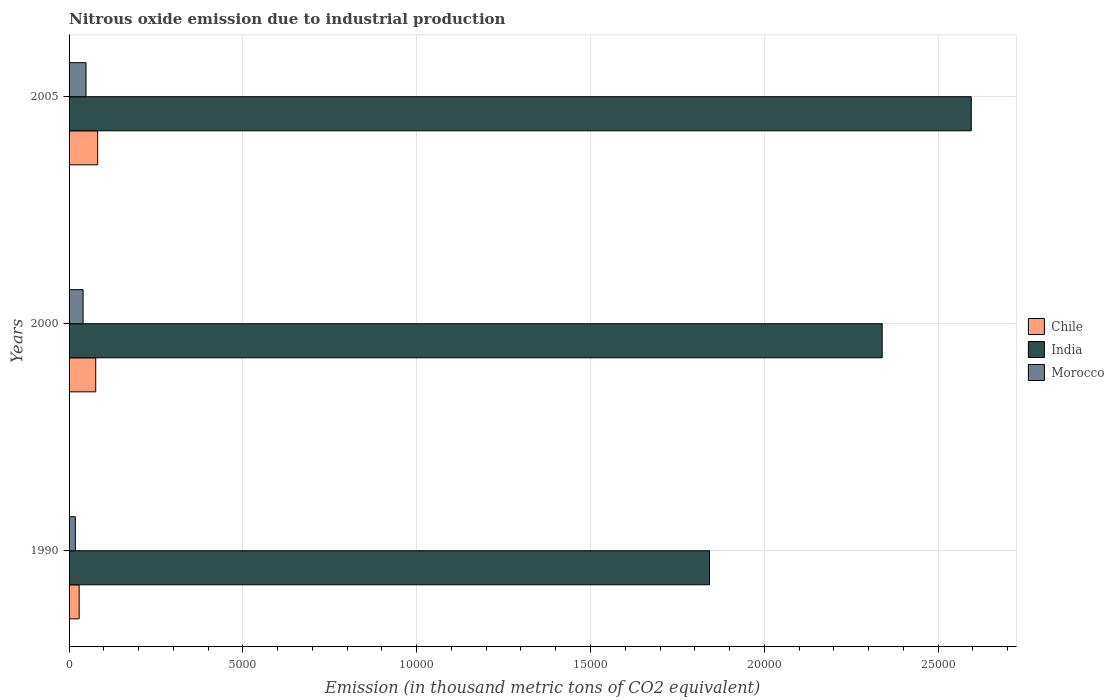How many different coloured bars are there?
Keep it short and to the point. 3. Are the number of bars on each tick of the Y-axis equal?
Provide a short and direct response. Yes. How many bars are there on the 1st tick from the top?
Offer a very short reply. 3. How many bars are there on the 1st tick from the bottom?
Ensure brevity in your answer.  3. In how many cases, is the number of bars for a given year not equal to the number of legend labels?
Your answer should be very brief. 0. What is the amount of nitrous oxide emitted in Chile in 1990?
Your response must be concise. 290.1. Across all years, what is the maximum amount of nitrous oxide emitted in Chile?
Your response must be concise. 822.2. Across all years, what is the minimum amount of nitrous oxide emitted in Chile?
Your answer should be compact. 290.1. In which year was the amount of nitrous oxide emitted in India maximum?
Make the answer very short. 2005. What is the total amount of nitrous oxide emitted in Chile in the graph?
Ensure brevity in your answer.  1879.2. What is the difference between the amount of nitrous oxide emitted in India in 1990 and that in 2000?
Your answer should be very brief. -4968.5. What is the difference between the amount of nitrous oxide emitted in Chile in 2005 and the amount of nitrous oxide emitted in Morocco in 2000?
Keep it short and to the point. 419.1. What is the average amount of nitrous oxide emitted in Chile per year?
Provide a short and direct response. 626.4. In the year 1990, what is the difference between the amount of nitrous oxide emitted in India and amount of nitrous oxide emitted in Morocco?
Make the answer very short. 1.82e+04. In how many years, is the amount of nitrous oxide emitted in Chile greater than 26000 thousand metric tons?
Provide a succinct answer. 0. What is the ratio of the amount of nitrous oxide emitted in Morocco in 2000 to that in 2005?
Your answer should be compact. 0.83. Is the amount of nitrous oxide emitted in Chile in 2000 less than that in 2005?
Offer a terse response. Yes. Is the difference between the amount of nitrous oxide emitted in India in 1990 and 2000 greater than the difference between the amount of nitrous oxide emitted in Morocco in 1990 and 2000?
Offer a very short reply. No. What is the difference between the highest and the second highest amount of nitrous oxide emitted in Morocco?
Your response must be concise. 84.3. What is the difference between the highest and the lowest amount of nitrous oxide emitted in Chile?
Give a very brief answer. 532.1. How many years are there in the graph?
Give a very brief answer. 3. Are the values on the major ticks of X-axis written in scientific E-notation?
Ensure brevity in your answer.  No. Does the graph contain any zero values?
Give a very brief answer. No. How many legend labels are there?
Your response must be concise. 3. How are the legend labels stacked?
Provide a succinct answer. Vertical. What is the title of the graph?
Make the answer very short. Nitrous oxide emission due to industrial production. Does "Pakistan" appear as one of the legend labels in the graph?
Your answer should be compact. No. What is the label or title of the X-axis?
Your response must be concise. Emission (in thousand metric tons of CO2 equivalent). What is the label or title of the Y-axis?
Your answer should be compact. Years. What is the Emission (in thousand metric tons of CO2 equivalent) in Chile in 1990?
Your response must be concise. 290.1. What is the Emission (in thousand metric tons of CO2 equivalent) of India in 1990?
Provide a succinct answer. 1.84e+04. What is the Emission (in thousand metric tons of CO2 equivalent) of Morocco in 1990?
Provide a short and direct response. 180.9. What is the Emission (in thousand metric tons of CO2 equivalent) in Chile in 2000?
Your answer should be compact. 766.9. What is the Emission (in thousand metric tons of CO2 equivalent) of India in 2000?
Your answer should be compact. 2.34e+04. What is the Emission (in thousand metric tons of CO2 equivalent) in Morocco in 2000?
Provide a short and direct response. 403.1. What is the Emission (in thousand metric tons of CO2 equivalent) of Chile in 2005?
Your response must be concise. 822.2. What is the Emission (in thousand metric tons of CO2 equivalent) in India in 2005?
Your answer should be very brief. 2.60e+04. What is the Emission (in thousand metric tons of CO2 equivalent) of Morocco in 2005?
Make the answer very short. 487.4. Across all years, what is the maximum Emission (in thousand metric tons of CO2 equivalent) of Chile?
Your answer should be very brief. 822.2. Across all years, what is the maximum Emission (in thousand metric tons of CO2 equivalent) in India?
Provide a succinct answer. 2.60e+04. Across all years, what is the maximum Emission (in thousand metric tons of CO2 equivalent) of Morocco?
Make the answer very short. 487.4. Across all years, what is the minimum Emission (in thousand metric tons of CO2 equivalent) of Chile?
Offer a very short reply. 290.1. Across all years, what is the minimum Emission (in thousand metric tons of CO2 equivalent) of India?
Offer a terse response. 1.84e+04. Across all years, what is the minimum Emission (in thousand metric tons of CO2 equivalent) of Morocco?
Your response must be concise. 180.9. What is the total Emission (in thousand metric tons of CO2 equivalent) in Chile in the graph?
Provide a short and direct response. 1879.2. What is the total Emission (in thousand metric tons of CO2 equivalent) of India in the graph?
Your answer should be compact. 6.78e+04. What is the total Emission (in thousand metric tons of CO2 equivalent) in Morocco in the graph?
Make the answer very short. 1071.4. What is the difference between the Emission (in thousand metric tons of CO2 equivalent) of Chile in 1990 and that in 2000?
Your answer should be very brief. -476.8. What is the difference between the Emission (in thousand metric tons of CO2 equivalent) in India in 1990 and that in 2000?
Ensure brevity in your answer.  -4968.5. What is the difference between the Emission (in thousand metric tons of CO2 equivalent) in Morocco in 1990 and that in 2000?
Your answer should be compact. -222.2. What is the difference between the Emission (in thousand metric tons of CO2 equivalent) in Chile in 1990 and that in 2005?
Provide a succinct answer. -532.1. What is the difference between the Emission (in thousand metric tons of CO2 equivalent) in India in 1990 and that in 2005?
Ensure brevity in your answer.  -7531.6. What is the difference between the Emission (in thousand metric tons of CO2 equivalent) in Morocco in 1990 and that in 2005?
Make the answer very short. -306.5. What is the difference between the Emission (in thousand metric tons of CO2 equivalent) of Chile in 2000 and that in 2005?
Ensure brevity in your answer.  -55.3. What is the difference between the Emission (in thousand metric tons of CO2 equivalent) of India in 2000 and that in 2005?
Provide a short and direct response. -2563.1. What is the difference between the Emission (in thousand metric tons of CO2 equivalent) in Morocco in 2000 and that in 2005?
Your answer should be compact. -84.3. What is the difference between the Emission (in thousand metric tons of CO2 equivalent) of Chile in 1990 and the Emission (in thousand metric tons of CO2 equivalent) of India in 2000?
Keep it short and to the point. -2.31e+04. What is the difference between the Emission (in thousand metric tons of CO2 equivalent) in Chile in 1990 and the Emission (in thousand metric tons of CO2 equivalent) in Morocco in 2000?
Ensure brevity in your answer.  -113. What is the difference between the Emission (in thousand metric tons of CO2 equivalent) in India in 1990 and the Emission (in thousand metric tons of CO2 equivalent) in Morocco in 2000?
Your response must be concise. 1.80e+04. What is the difference between the Emission (in thousand metric tons of CO2 equivalent) in Chile in 1990 and the Emission (in thousand metric tons of CO2 equivalent) in India in 2005?
Make the answer very short. -2.57e+04. What is the difference between the Emission (in thousand metric tons of CO2 equivalent) of Chile in 1990 and the Emission (in thousand metric tons of CO2 equivalent) of Morocco in 2005?
Offer a terse response. -197.3. What is the difference between the Emission (in thousand metric tons of CO2 equivalent) of India in 1990 and the Emission (in thousand metric tons of CO2 equivalent) of Morocco in 2005?
Your response must be concise. 1.79e+04. What is the difference between the Emission (in thousand metric tons of CO2 equivalent) in Chile in 2000 and the Emission (in thousand metric tons of CO2 equivalent) in India in 2005?
Your answer should be very brief. -2.52e+04. What is the difference between the Emission (in thousand metric tons of CO2 equivalent) of Chile in 2000 and the Emission (in thousand metric tons of CO2 equivalent) of Morocco in 2005?
Ensure brevity in your answer.  279.5. What is the difference between the Emission (in thousand metric tons of CO2 equivalent) of India in 2000 and the Emission (in thousand metric tons of CO2 equivalent) of Morocco in 2005?
Your answer should be very brief. 2.29e+04. What is the average Emission (in thousand metric tons of CO2 equivalent) of Chile per year?
Ensure brevity in your answer.  626.4. What is the average Emission (in thousand metric tons of CO2 equivalent) in India per year?
Give a very brief answer. 2.26e+04. What is the average Emission (in thousand metric tons of CO2 equivalent) in Morocco per year?
Your answer should be very brief. 357.13. In the year 1990, what is the difference between the Emission (in thousand metric tons of CO2 equivalent) in Chile and Emission (in thousand metric tons of CO2 equivalent) in India?
Your answer should be compact. -1.81e+04. In the year 1990, what is the difference between the Emission (in thousand metric tons of CO2 equivalent) in Chile and Emission (in thousand metric tons of CO2 equivalent) in Morocco?
Give a very brief answer. 109.2. In the year 1990, what is the difference between the Emission (in thousand metric tons of CO2 equivalent) of India and Emission (in thousand metric tons of CO2 equivalent) of Morocco?
Your response must be concise. 1.82e+04. In the year 2000, what is the difference between the Emission (in thousand metric tons of CO2 equivalent) of Chile and Emission (in thousand metric tons of CO2 equivalent) of India?
Make the answer very short. -2.26e+04. In the year 2000, what is the difference between the Emission (in thousand metric tons of CO2 equivalent) of Chile and Emission (in thousand metric tons of CO2 equivalent) of Morocco?
Your response must be concise. 363.8. In the year 2000, what is the difference between the Emission (in thousand metric tons of CO2 equivalent) of India and Emission (in thousand metric tons of CO2 equivalent) of Morocco?
Make the answer very short. 2.30e+04. In the year 2005, what is the difference between the Emission (in thousand metric tons of CO2 equivalent) of Chile and Emission (in thousand metric tons of CO2 equivalent) of India?
Make the answer very short. -2.51e+04. In the year 2005, what is the difference between the Emission (in thousand metric tons of CO2 equivalent) in Chile and Emission (in thousand metric tons of CO2 equivalent) in Morocco?
Your answer should be very brief. 334.8. In the year 2005, what is the difference between the Emission (in thousand metric tons of CO2 equivalent) of India and Emission (in thousand metric tons of CO2 equivalent) of Morocco?
Keep it short and to the point. 2.55e+04. What is the ratio of the Emission (in thousand metric tons of CO2 equivalent) of Chile in 1990 to that in 2000?
Offer a terse response. 0.38. What is the ratio of the Emission (in thousand metric tons of CO2 equivalent) in India in 1990 to that in 2000?
Your answer should be compact. 0.79. What is the ratio of the Emission (in thousand metric tons of CO2 equivalent) in Morocco in 1990 to that in 2000?
Your response must be concise. 0.45. What is the ratio of the Emission (in thousand metric tons of CO2 equivalent) of Chile in 1990 to that in 2005?
Your answer should be very brief. 0.35. What is the ratio of the Emission (in thousand metric tons of CO2 equivalent) in India in 1990 to that in 2005?
Make the answer very short. 0.71. What is the ratio of the Emission (in thousand metric tons of CO2 equivalent) in Morocco in 1990 to that in 2005?
Make the answer very short. 0.37. What is the ratio of the Emission (in thousand metric tons of CO2 equivalent) of Chile in 2000 to that in 2005?
Provide a short and direct response. 0.93. What is the ratio of the Emission (in thousand metric tons of CO2 equivalent) in India in 2000 to that in 2005?
Offer a very short reply. 0.9. What is the ratio of the Emission (in thousand metric tons of CO2 equivalent) in Morocco in 2000 to that in 2005?
Your answer should be compact. 0.83. What is the difference between the highest and the second highest Emission (in thousand metric tons of CO2 equivalent) of Chile?
Offer a terse response. 55.3. What is the difference between the highest and the second highest Emission (in thousand metric tons of CO2 equivalent) of India?
Your answer should be very brief. 2563.1. What is the difference between the highest and the second highest Emission (in thousand metric tons of CO2 equivalent) in Morocco?
Your response must be concise. 84.3. What is the difference between the highest and the lowest Emission (in thousand metric tons of CO2 equivalent) in Chile?
Make the answer very short. 532.1. What is the difference between the highest and the lowest Emission (in thousand metric tons of CO2 equivalent) of India?
Your answer should be compact. 7531.6. What is the difference between the highest and the lowest Emission (in thousand metric tons of CO2 equivalent) of Morocco?
Give a very brief answer. 306.5. 